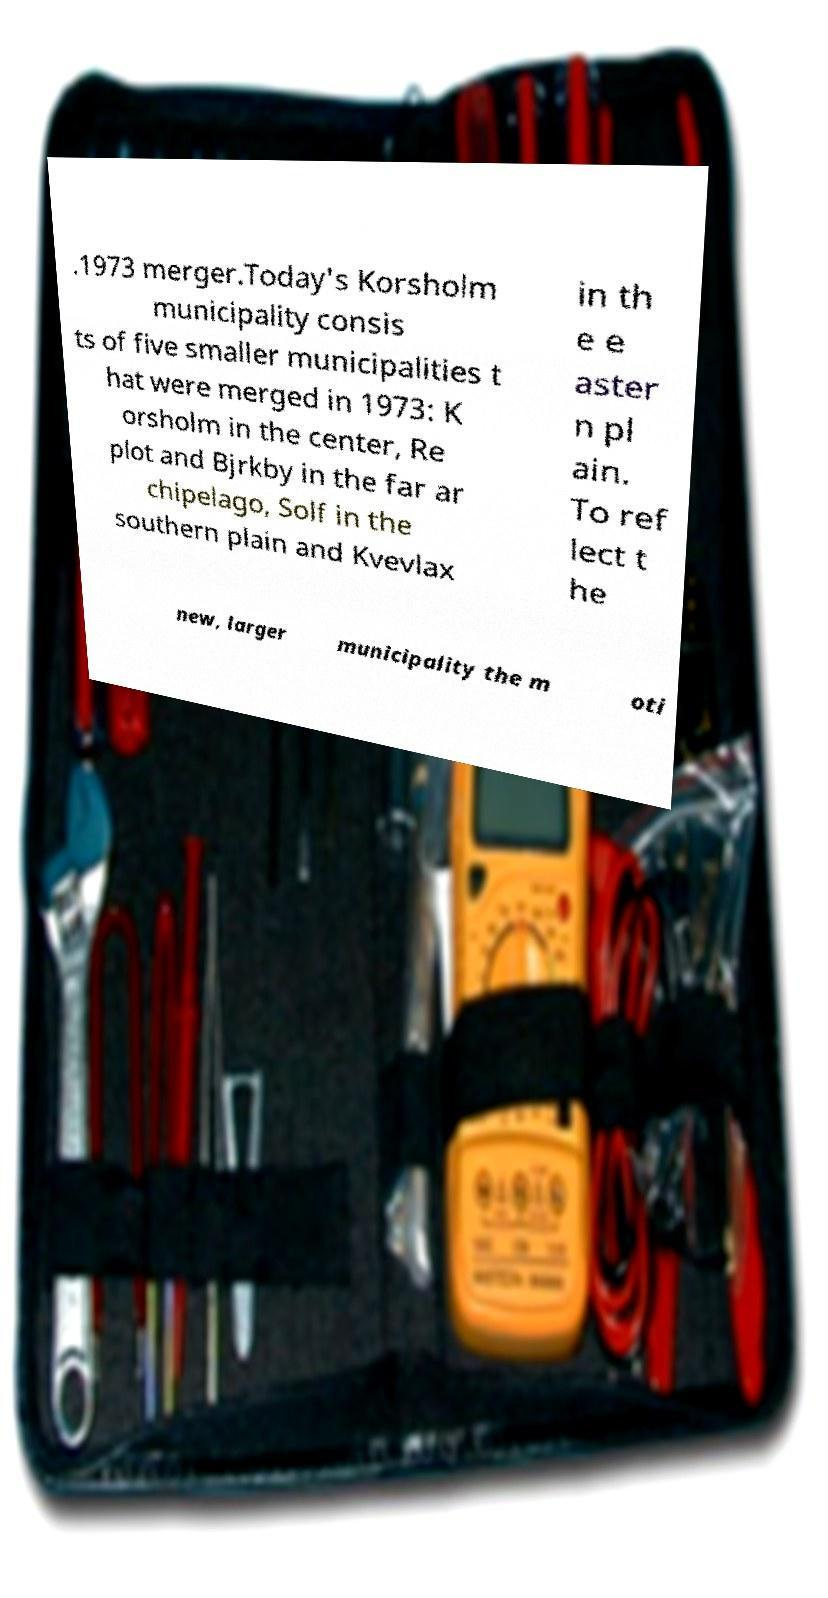I need the written content from this picture converted into text. Can you do that? .1973 merger.Today's Korsholm municipality consis ts of five smaller municipalities t hat were merged in 1973: K orsholm in the center, Re plot and Bjrkby in the far ar chipelago, Solf in the southern plain and Kvevlax in th e e aster n pl ain. To ref lect t he new, larger municipality the m oti 